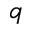<formula> <loc_0><loc_0><loc_500><loc_500>q</formula> 